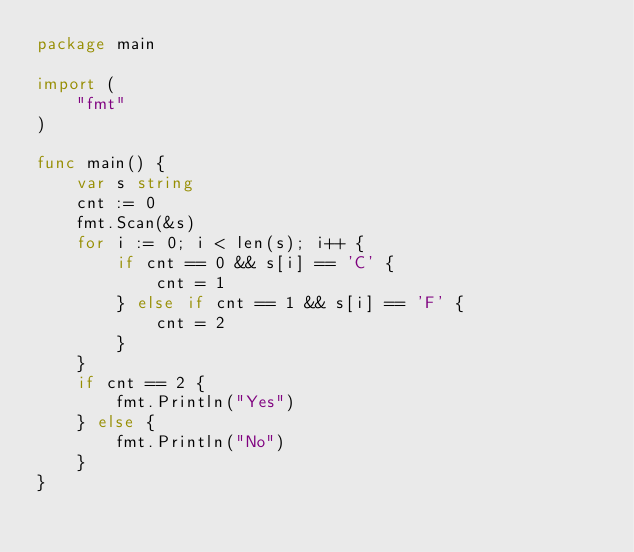<code> <loc_0><loc_0><loc_500><loc_500><_Go_>package main

import (
	"fmt"
)

func main() {
	var s string
	cnt := 0
	fmt.Scan(&s)
	for i := 0; i < len(s); i++ {
		if cnt == 0 && s[i] == 'C' {
			cnt = 1
		} else if cnt == 1 && s[i] == 'F' {
			cnt = 2
		}
	}
	if cnt == 2 {
		fmt.Println("Yes")
	} else {
		fmt.Println("No")
	}
}
</code> 